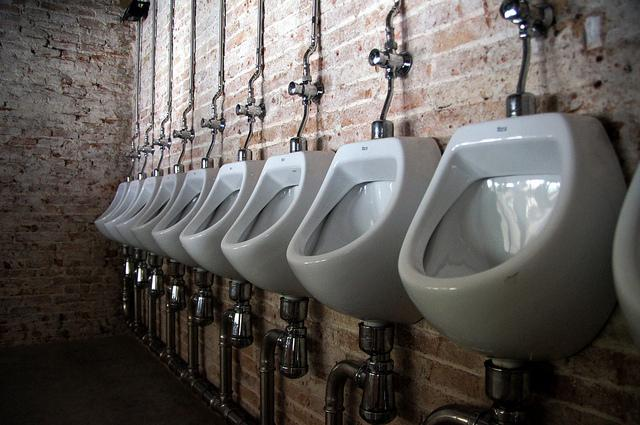What are these white objects used to hold? urine 